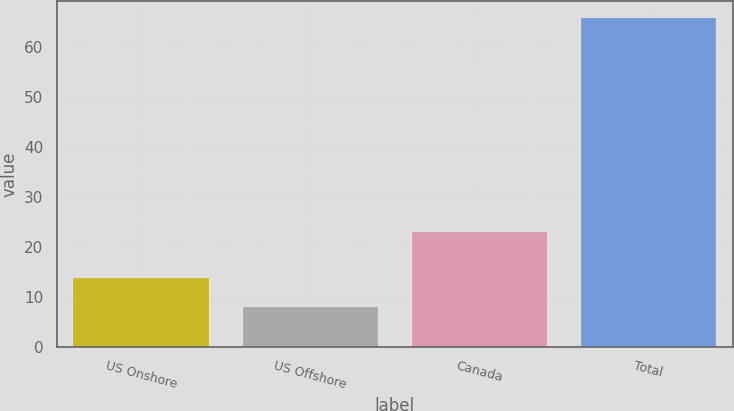Convert chart to OTSL. <chart><loc_0><loc_0><loc_500><loc_500><bar_chart><fcel>US Onshore<fcel>US Offshore<fcel>Canada<fcel>Total<nl><fcel>13.8<fcel>8<fcel>23<fcel>66<nl></chart> 